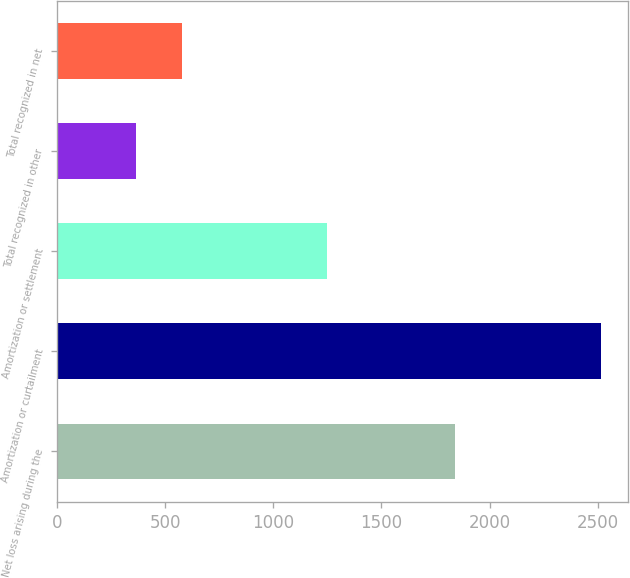Convert chart. <chart><loc_0><loc_0><loc_500><loc_500><bar_chart><fcel>Net loss arising during the<fcel>Amortization or curtailment<fcel>Amortization or settlement<fcel>Total recognized in other<fcel>Total recognized in net<nl><fcel>1839<fcel>2515<fcel>1246<fcel>364<fcel>579.1<nl></chart> 